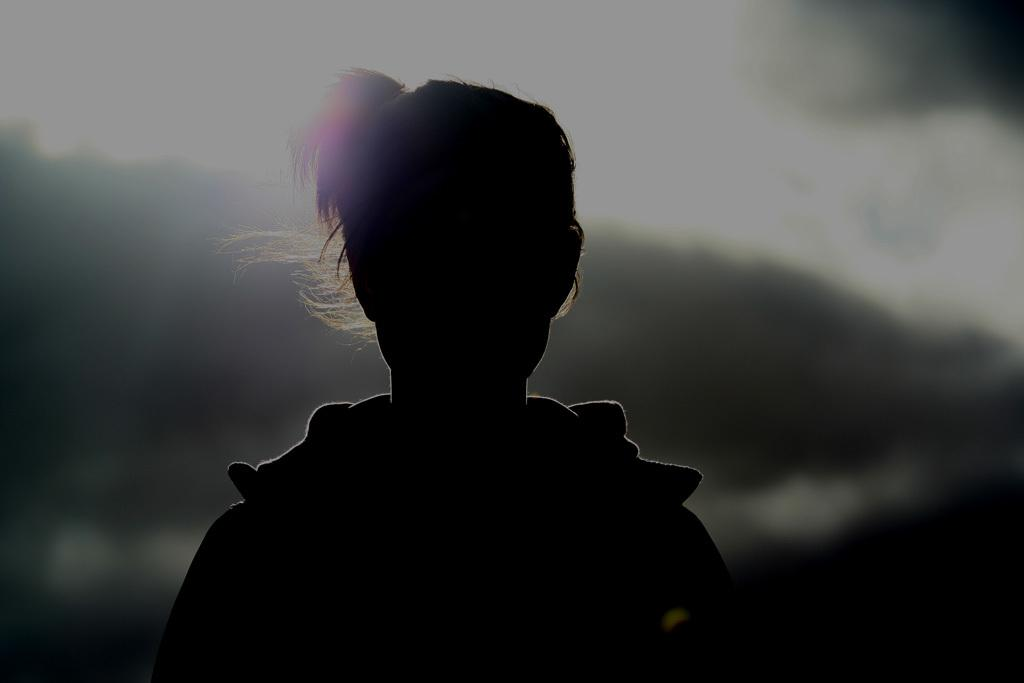What is the main subject of the image? There is a person in the image. Can you describe the background of the image? The background of the image is blurred. Is the person in the image sinking into quicksand? There is no quicksand present in the image, and the person is not sinking into anything. 